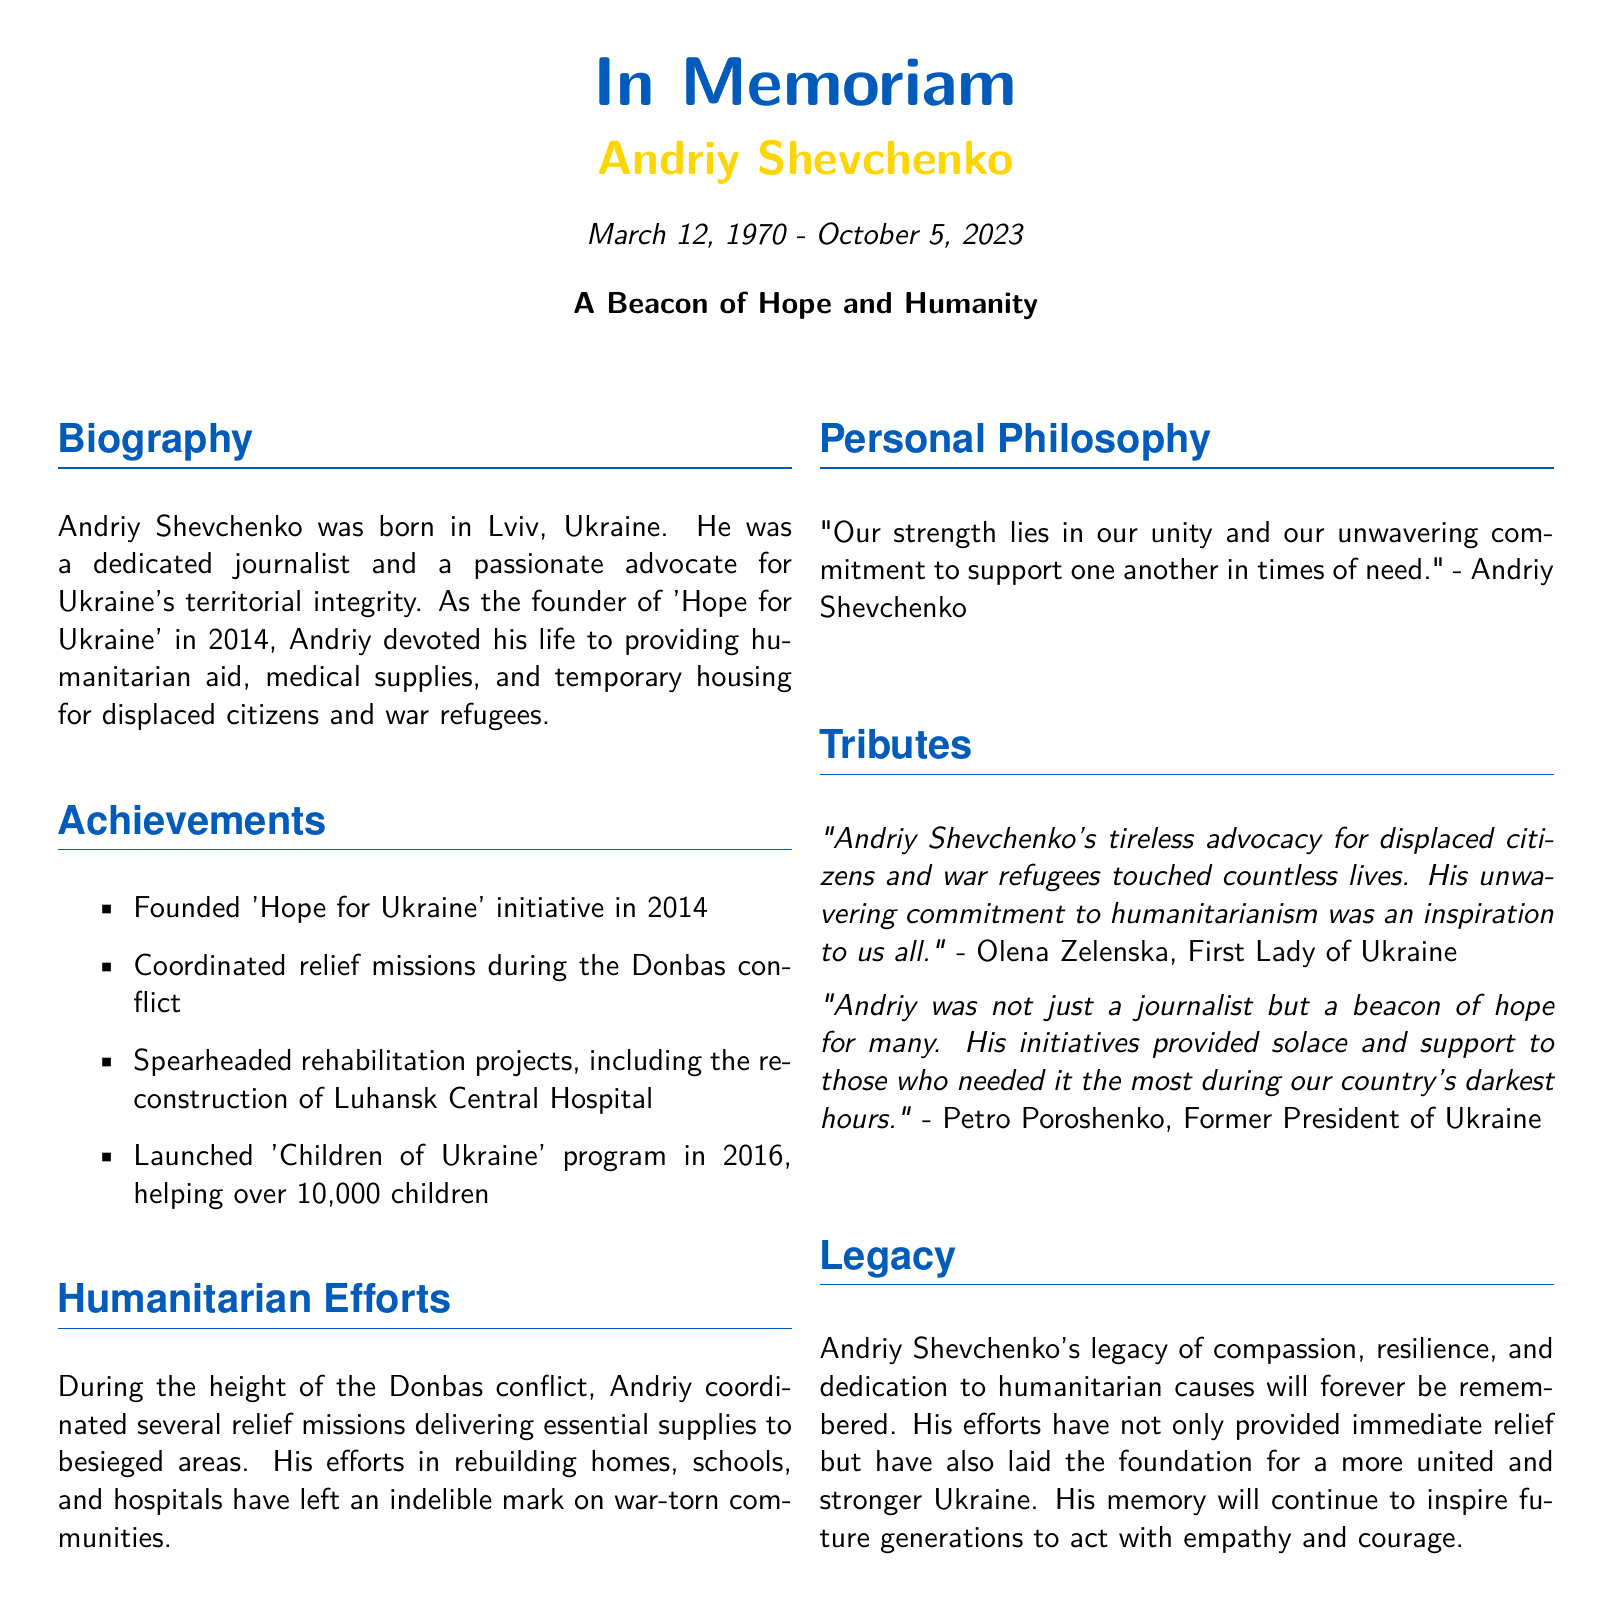What is the full name of the community leader? The full name of the community leader mentioned in the obituary is Andriy Shevchenko.
Answer: Andriy Shevchenko What was Andriy Shevchenko's birth date? The document states that Andriy Shevchenko was born on March 12, 1970.
Answer: March 12, 1970 What initiative did Andriy Shevchenko found in 2014? The initiative founded by Andriy Shevchenko in 2014 is called 'Hope for Ukraine'.
Answer: 'Hope for Ukraine' How many children did the 'Children of Ukraine' program help? The program helped over 10,000 children according to the document.
Answer: over 10,000 children Who quoted Andriy Shevchenko's personal philosophy? The quoted personal philosophy is attributed to Andriy Shevchenko himself.
Answer: Andriy Shevchenko What was one of the major projects Andriy Shevchenko spearheaded? The reconstruction of Luhansk Central Hospital is mentioned as one of the major projects he spearheaded.
Answer: Luhansk Central Hospital What did Olena Zelenska say about Andriy Shevchenko? Olena Zelenska commented on his tireless advocacy for displaced citizens and war refugees.
Answer: tireless advocacy for displaced citizens What was Andriy Shevchenko's legacy focused on? His legacy is focused on compassion, resilience, and dedication to humanitarian causes.
Answer: compassion, resilience, and dedication 